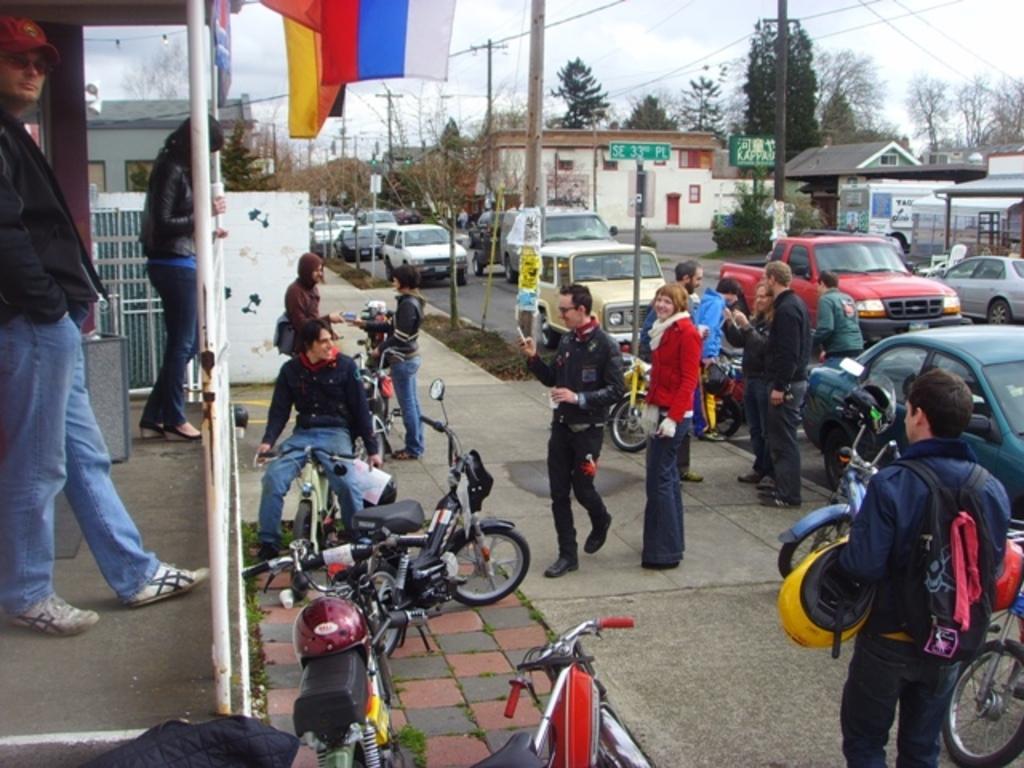In one or two sentences, can you explain what this image depicts? In this image, we can see a group of people. Few are standing and sitting. Here we can see few vehicles, trees, houses, poles, grill, walls. Background there is a sky. here we can see few people are smiling. 